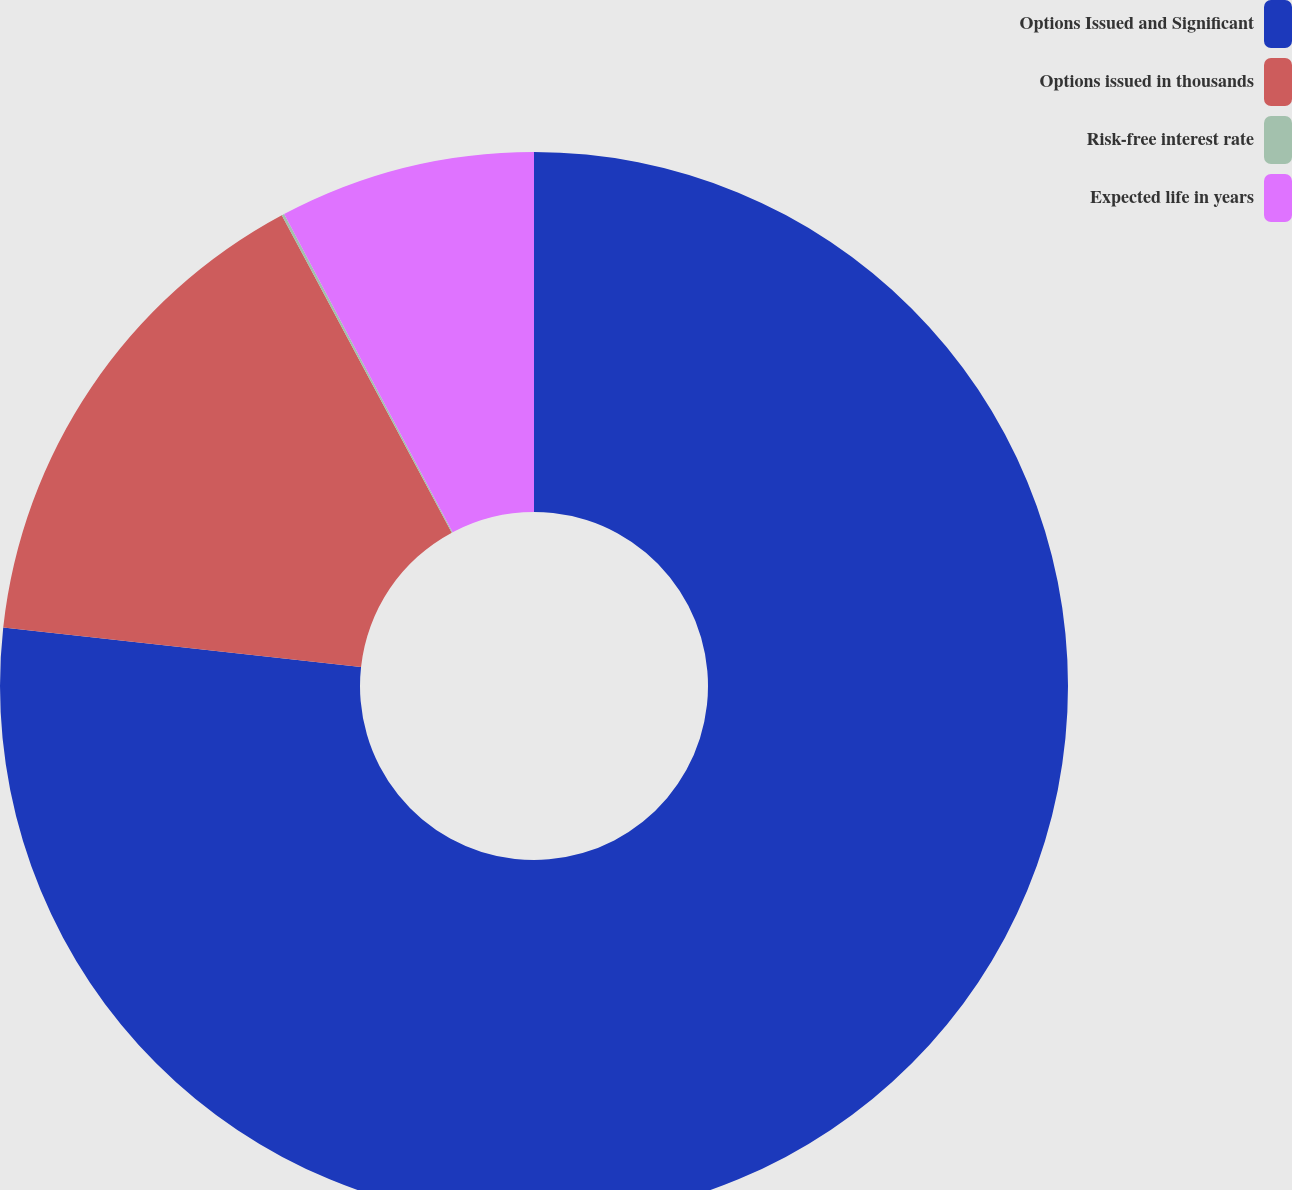Convert chart. <chart><loc_0><loc_0><loc_500><loc_500><pie_chart><fcel>Options Issued and Significant<fcel>Options issued in thousands<fcel>Risk-free interest rate<fcel>Expected life in years<nl><fcel>76.75%<fcel>15.42%<fcel>0.08%<fcel>7.75%<nl></chart> 